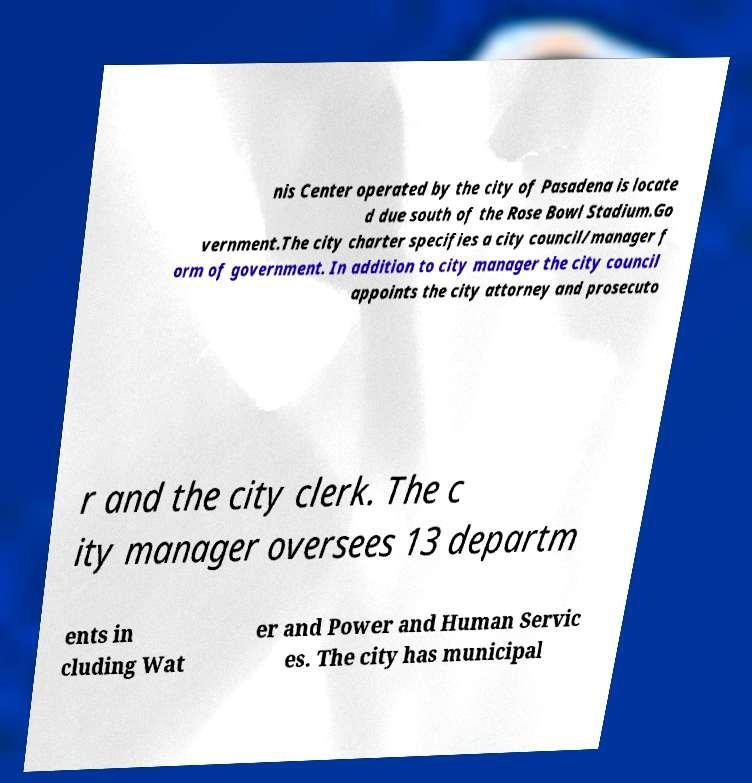There's text embedded in this image that I need extracted. Can you transcribe it verbatim? nis Center operated by the city of Pasadena is locate d due south of the Rose Bowl Stadium.Go vernment.The city charter specifies a city council/manager f orm of government. In addition to city manager the city council appoints the city attorney and prosecuto r and the city clerk. The c ity manager oversees 13 departm ents in cluding Wat er and Power and Human Servic es. The city has municipal 